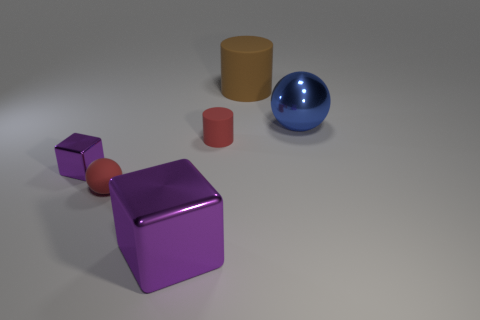Do the tiny ball and the tiny matte cylinder have the same color?
Give a very brief answer. Yes. Is the shape of the big brown matte object the same as the small rubber thing behind the small ball?
Your response must be concise. Yes. What number of small objects are either cyan rubber cylinders or red matte things?
Your answer should be very brief. 2. The other metal block that is the same color as the tiny block is what size?
Ensure brevity in your answer.  Large. What color is the rubber cylinder left of the rubber cylinder that is behind the blue metallic ball?
Offer a terse response. Red. Is the large sphere made of the same material as the red object that is on the right side of the big purple object?
Offer a terse response. No. What is the ball that is in front of the large blue object made of?
Your answer should be compact. Rubber. Are there an equal number of small purple metal objects in front of the tiny metallic object and brown rubber cylinders?
Your response must be concise. No. What material is the red object behind the red object in front of the tiny red matte cylinder?
Provide a succinct answer. Rubber. The metal thing that is both to the left of the large blue sphere and right of the small red matte ball has what shape?
Your response must be concise. Cube. 